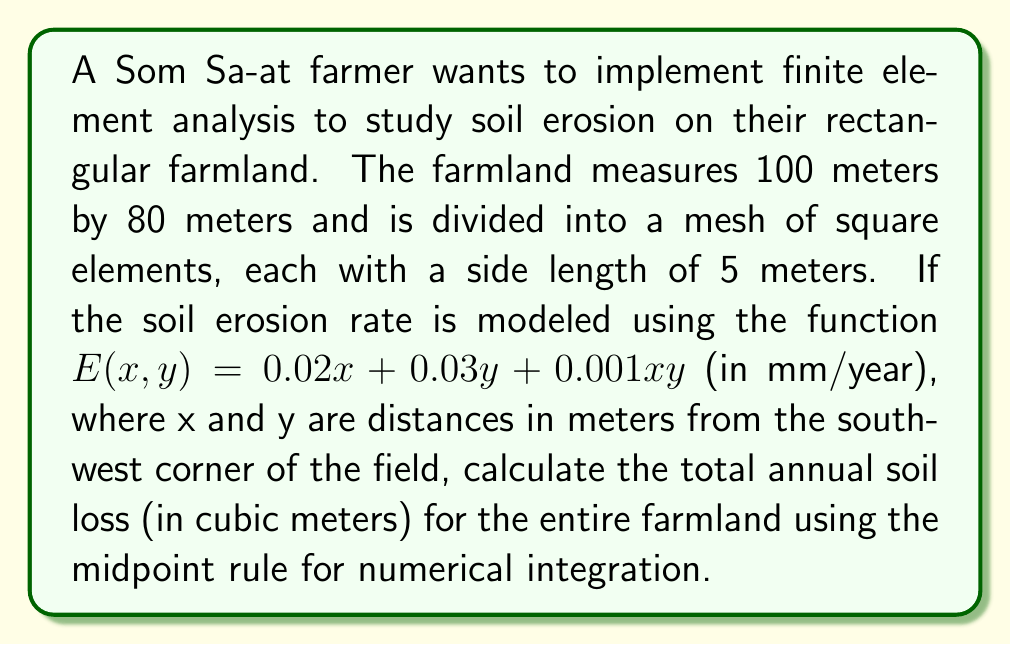Give your solution to this math problem. To solve this problem, we'll follow these steps:

1) First, let's determine the number of elements in our mesh:
   - In x-direction: 100 m / 5 m = 20 elements
   - In y-direction: 80 m / 5 m = 16 elements
   Total elements: 20 * 16 = 320 elements

2) The midpoint rule approximates the integral by evaluating the function at the center of each element and multiplying by the element area. For each element:
   Area = 5 m * 5 m = 25 m²

3) We need to find the coordinates of the midpoint of each element. The general formula for the midpoint coordinates will be:
   $x_m = 2.5 + 5i$, where $i = 0, 1, 2, ..., 19$
   $y_m = 2.5 + 5j$, where $j = 0, 1, 2, ..., 15$

4) The erosion at each midpoint is:
   $E(x_m, y_m) = 0.02(2.5 + 5i) + 0.03(2.5 + 5j) + 0.001(2.5 + 5i)(2.5 + 5j)$

5) The total erosion is the sum of erosion at all midpoints multiplied by the element area:

   $$E_{total} = 25 \sum_{i=0}^{19} \sum_{j=0}^{15} [0.02(2.5 + 5i) + 0.03(2.5 + 5j) + 0.001(2.5 + 5i)(2.5 + 5j)]$$

6) This double sum can be simplified using the formulas for the sum of arithmetic sequences:
   $$\sum_{k=0}^{n-1} k = \frac{n(n-1)}{2}$$
   $$\sum_{k=0}^{n-1} (a + bk) = na + \frac{bn(n-1)}{2}$$

7) After simplification and calculation:
   $$E_{total} = 25 * 20 * 16 * [0.02 * 52.5 + 0.03 * 42.5 + 0.001 * 52.5 * 42.5] = 106,000 \text{ mm/year}$$

8) Convert mm/year to m³/year:
   $106,000 \text{ mm/year} * (1 \text{ m} / 1000 \text{ mm}) * (100 \text{ m} * 80 \text{ m}) = 848 \text{ m³/year}$
Answer: The total annual soil loss for the entire farmland is approximately 848 cubic meters per year. 